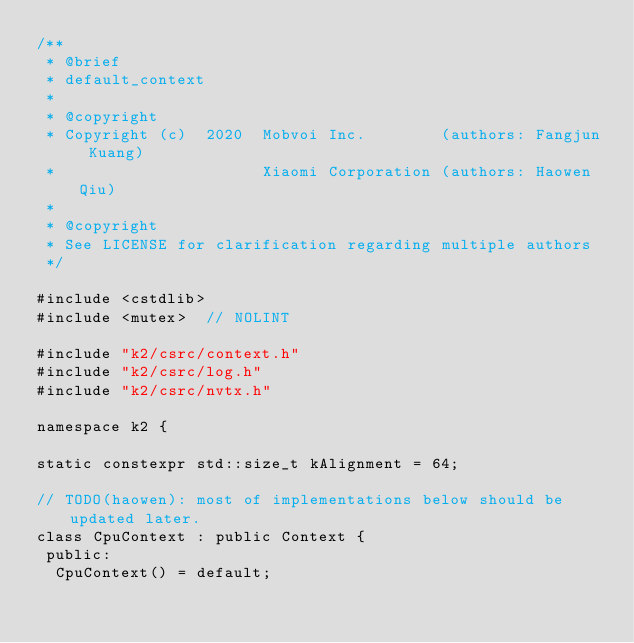Convert code to text. <code><loc_0><loc_0><loc_500><loc_500><_Cuda_>/**
 * @brief
 * default_context
 *
 * @copyright
 * Copyright (c)  2020  Mobvoi Inc.        (authors: Fangjun Kuang)
 *                      Xiaomi Corporation (authors: Haowen Qiu)
 *
 * @copyright
 * See LICENSE for clarification regarding multiple authors
 */

#include <cstdlib>
#include <mutex>  // NOLINT

#include "k2/csrc/context.h"
#include "k2/csrc/log.h"
#include "k2/csrc/nvtx.h"

namespace k2 {

static constexpr std::size_t kAlignment = 64;

// TODO(haowen): most of implementations below should be updated later.
class CpuContext : public Context {
 public:
  CpuContext() = default;</code> 